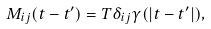<formula> <loc_0><loc_0><loc_500><loc_500>M _ { i j } ( t - t ^ { \prime } ) = T \delta _ { i j } \gamma ( | t - t ^ { \prime } | ) ,</formula> 